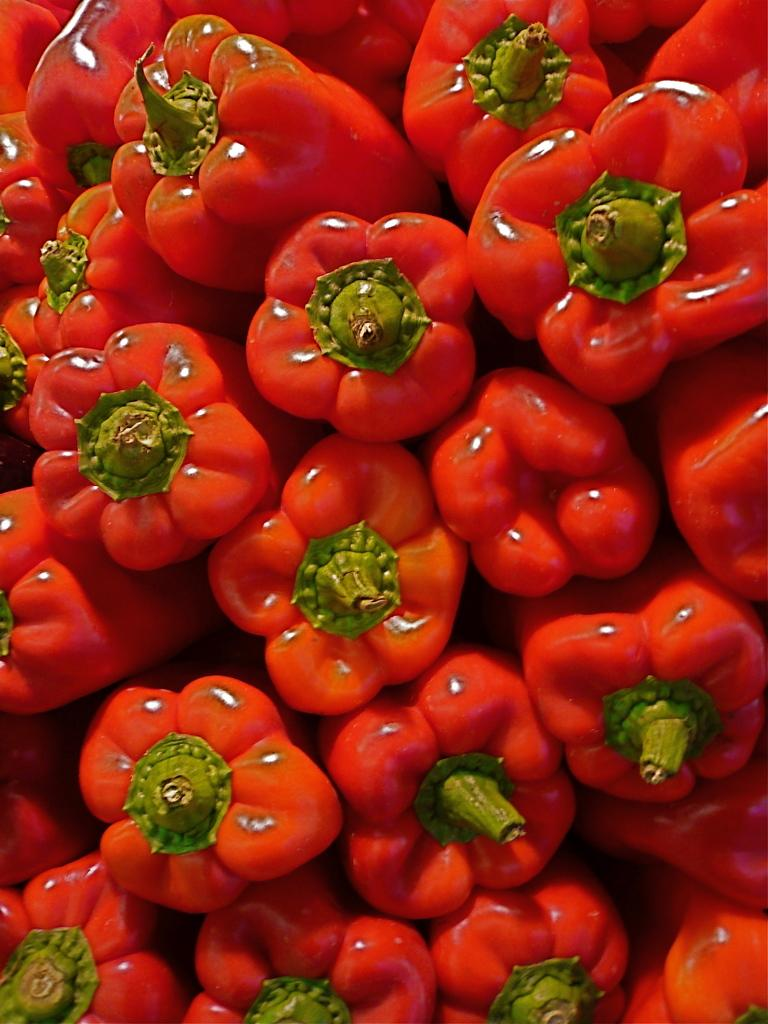What type of vegetable is present in the image? There are red color capsicums in the image. Can you describe the color of the capsicums? The capsicums in the image are red in color. What type of sweater is being worn by the capsicum in the image? There are no people or clothing items present in the image, only capsicums. 